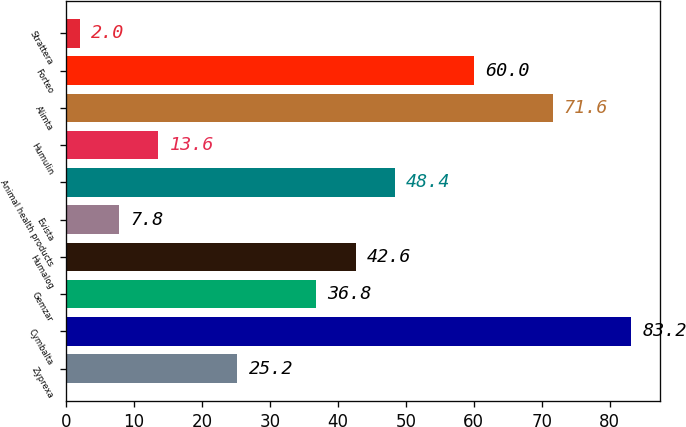Convert chart. <chart><loc_0><loc_0><loc_500><loc_500><bar_chart><fcel>Zyprexa<fcel>Cymbalta<fcel>Gemzar<fcel>Humalog<fcel>Evista<fcel>Animal health products<fcel>Humulin<fcel>Alimta<fcel>Forteo<fcel>Strattera<nl><fcel>25.2<fcel>83.2<fcel>36.8<fcel>42.6<fcel>7.8<fcel>48.4<fcel>13.6<fcel>71.6<fcel>60<fcel>2<nl></chart> 